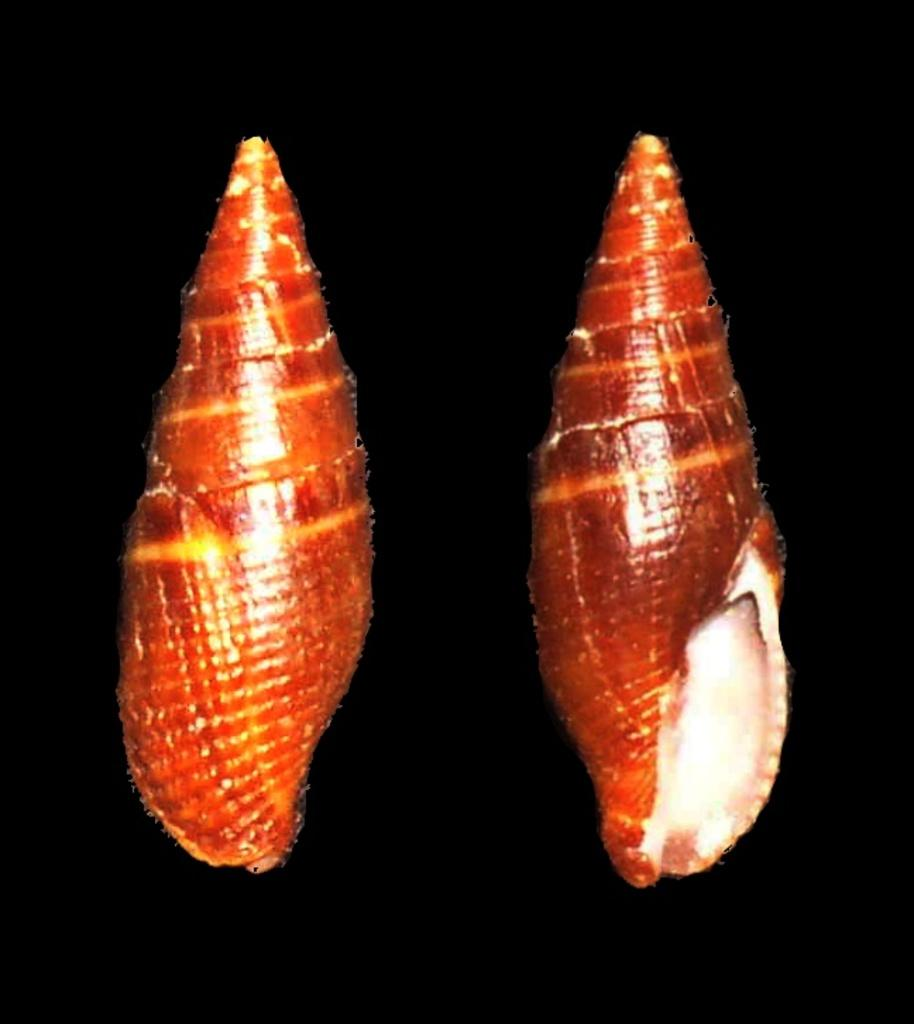What color are the shells in the image? The shells in the image are orange in color. Can you see the moon in the image? No, the moon is not present in the image; it only features orange color shells. 